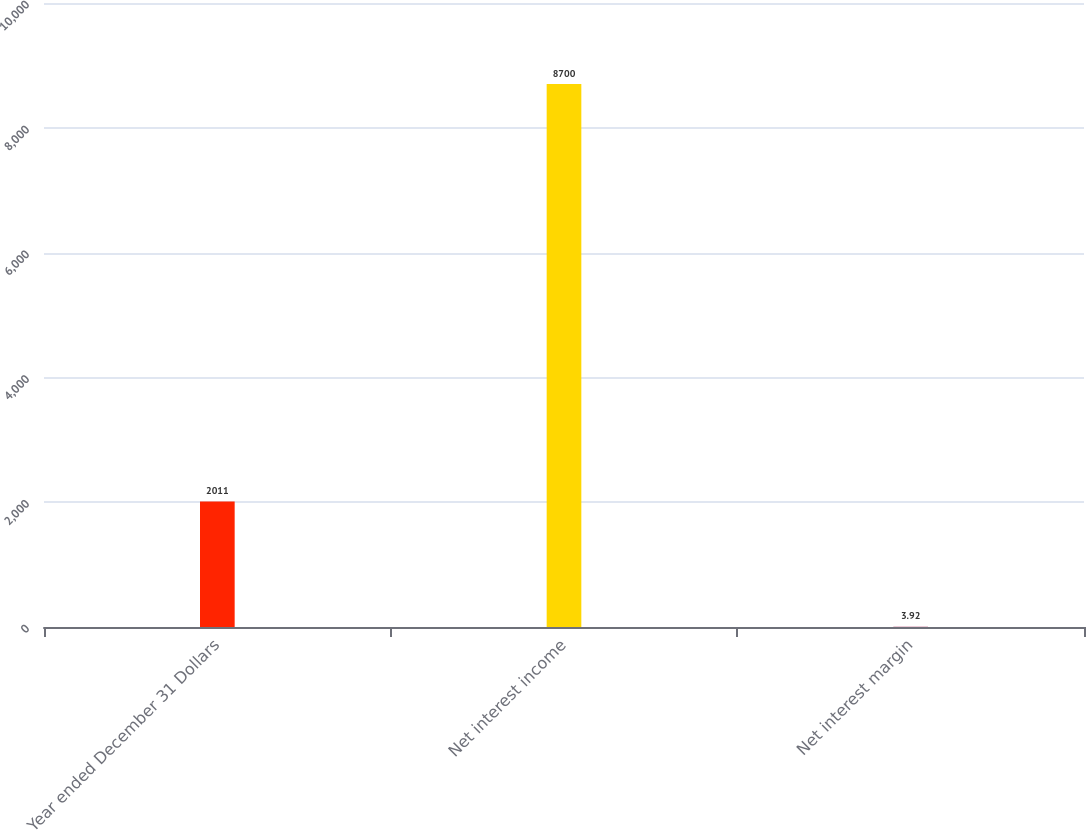Convert chart to OTSL. <chart><loc_0><loc_0><loc_500><loc_500><bar_chart><fcel>Year ended December 31 Dollars<fcel>Net interest income<fcel>Net interest margin<nl><fcel>2011<fcel>8700<fcel>3.92<nl></chart> 